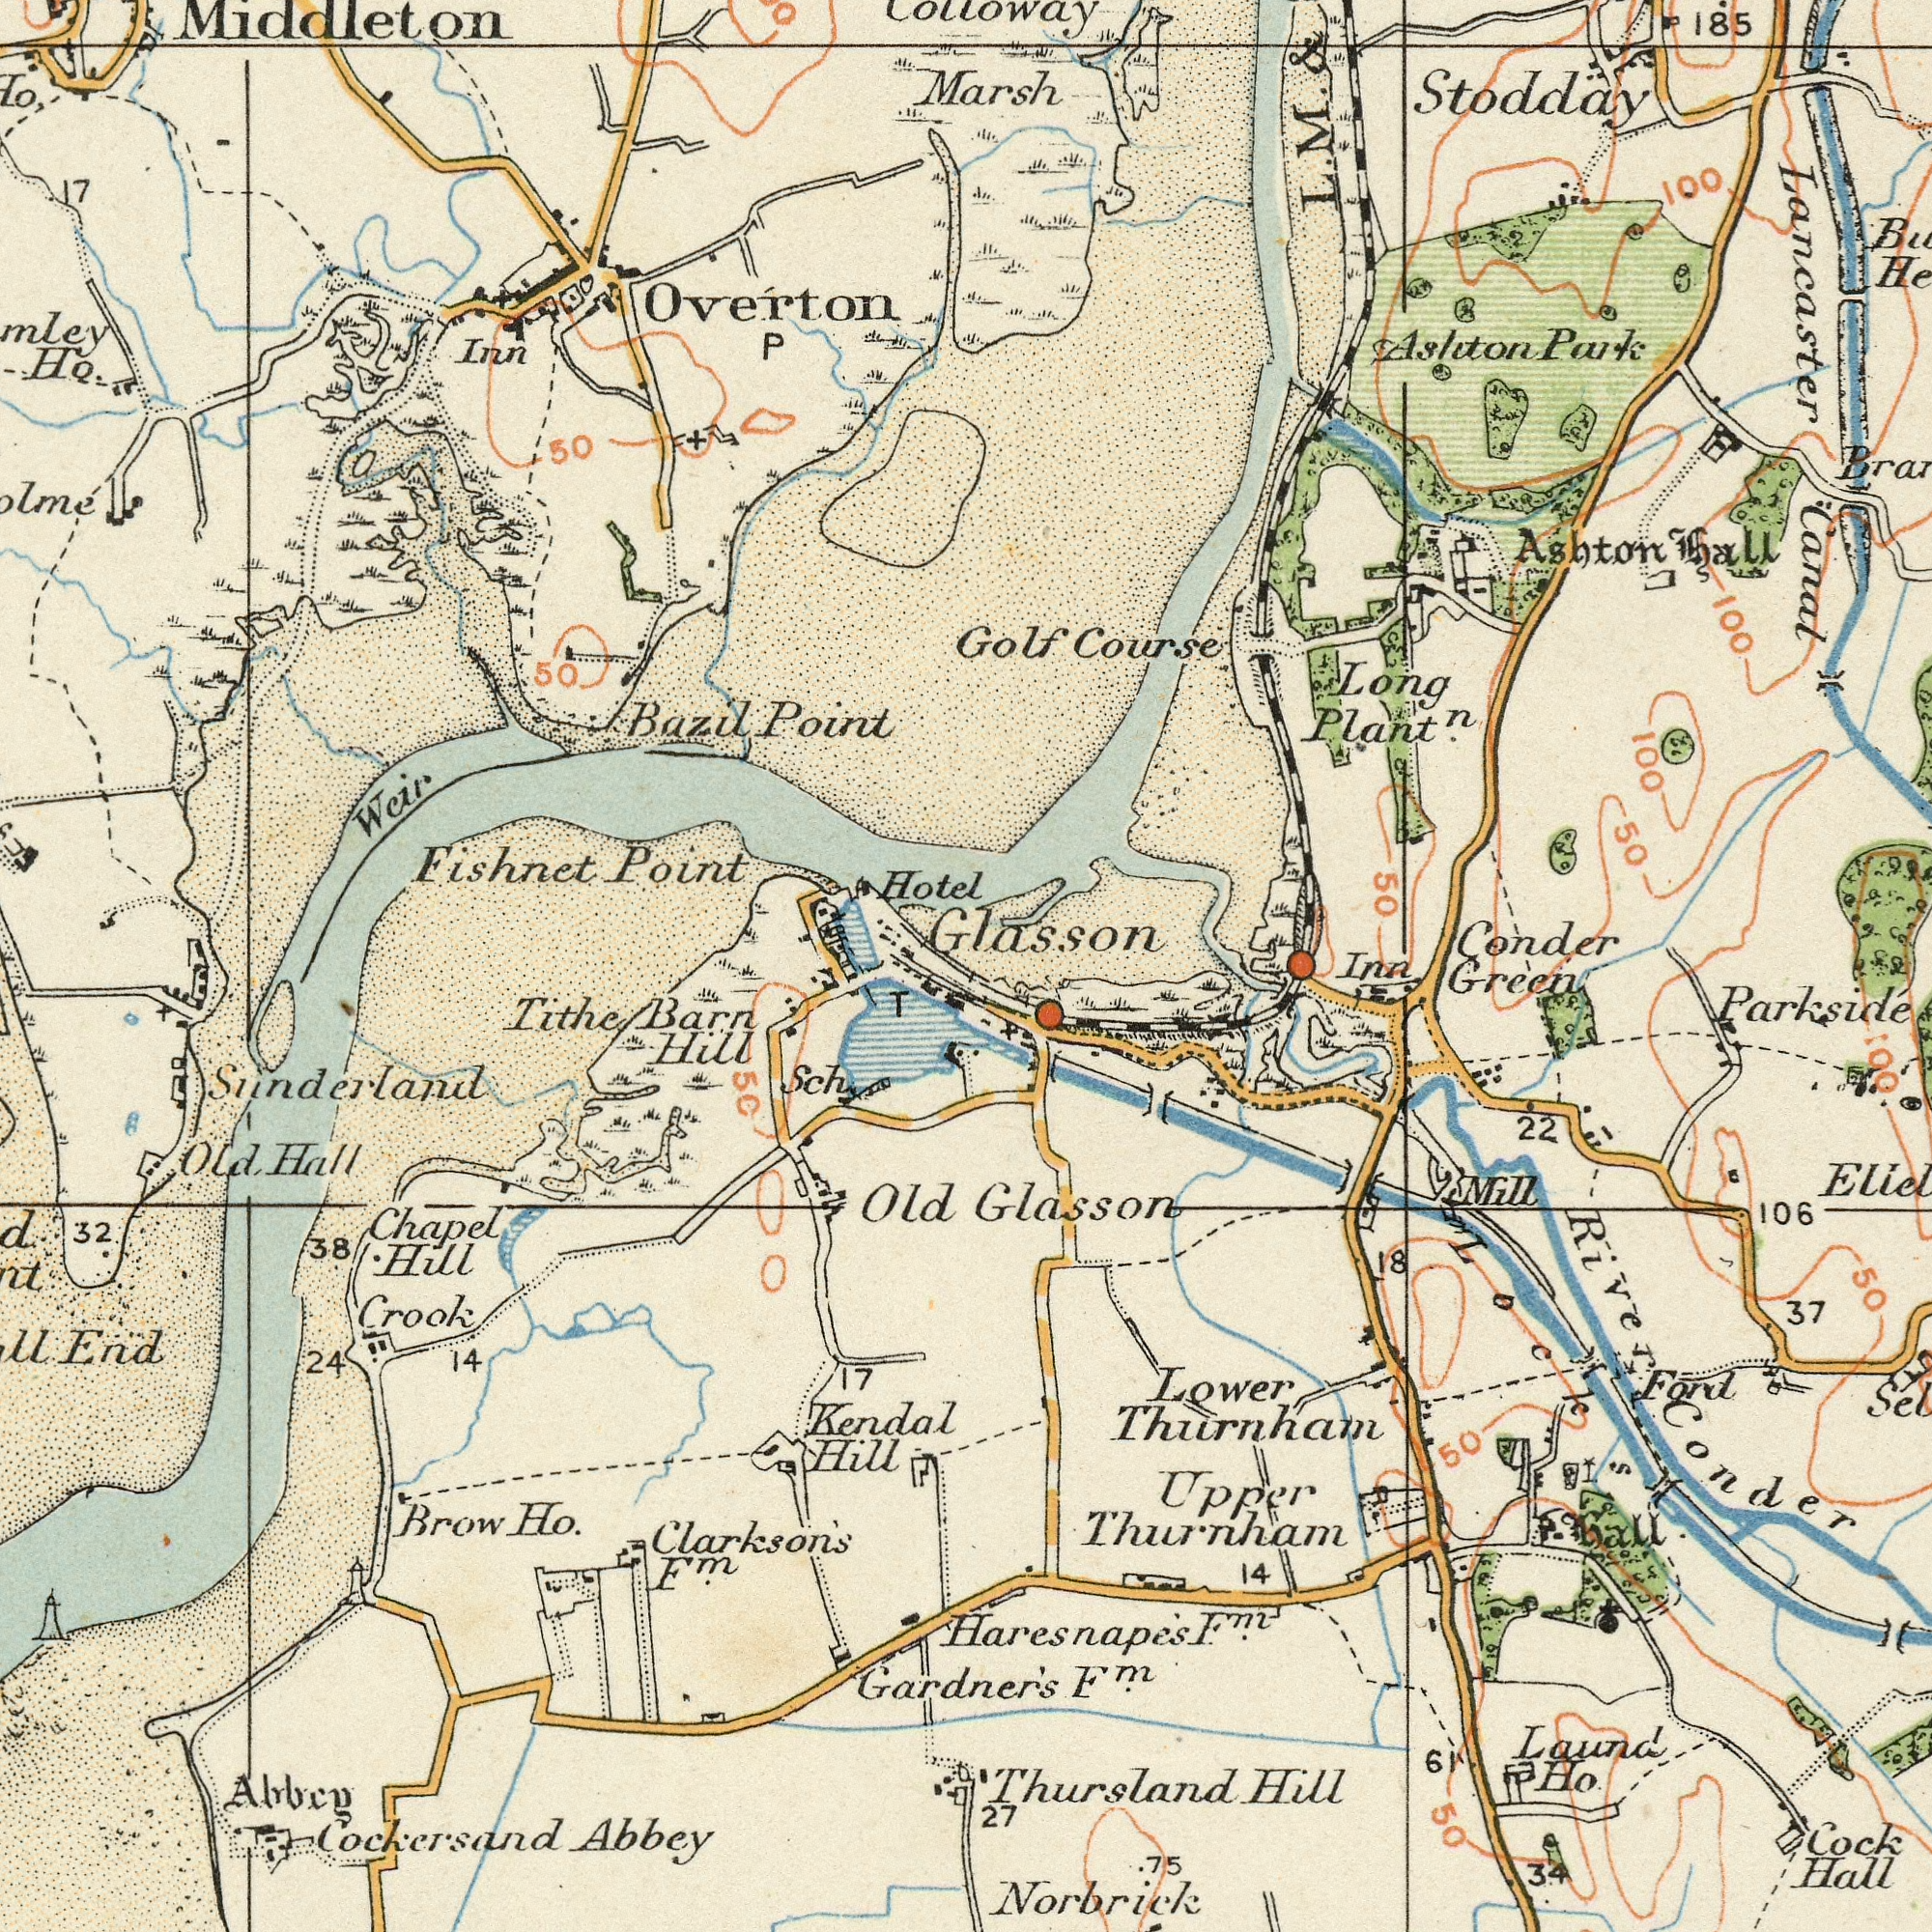What text is shown in the top-right quadrant? Stodday Conder Long Course Golf Ashton Canal Lancaster 100 100 50 100 hall 50 Colloway L. M. & 185 Marsh Ashton Park Plant<sup>n</sup>. Glasson What text is visible in the lower-right corner? Cock Glasson Thursland Lower Hall Green Ford Laund Mill Thurnham Hill Conder 37 Thurnham Upper 22 34 Norbrick 106 61 14 50 27 18 Ho. 50 F<sup>m</sup>. Parkside 75 Inn Lock River 50 Hall F<sup>m</sup>. Haresnape's 100 What text appears in the top-left area of the image? Fishnet Point Point Bazil Weir 17 Middleton 50 50 Overton Ho. Inn Hotel What text can you see in the bottom-left section? Abbey Old Brow End Chapel Barn Kendal Hill Tithe 32 Ho. Hill Hill Cockersand Clarkson's Hall Albeg 24 38 14 Crook Sch 17 Old 50 T Sunderland F<sup>m</sup>. Gardner's 